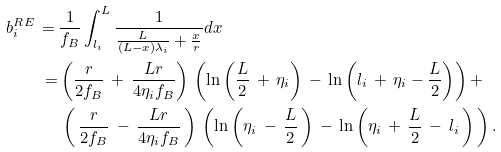<formula> <loc_0><loc_0><loc_500><loc_500>b _ { i } ^ { R E } \, = \, & \frac { 1 } { f _ { B } } \int _ { l _ { i } } ^ { L } \frac { 1 } { \frac { L } { ( L - x ) \lambda _ { i } } + \frac { x } { r } } d x \\ = & \left ( \frac { r } { 2 f _ { B } } \, + \, \frac { L r } { 4 \eta _ { i } f _ { B } } \right ) \, \left ( \ln \left ( \frac { L } { 2 } \, + \, \eta _ { i } \right ) \, - \, \ln \left ( l _ { i } \, + \, \eta _ { i } - \frac { L } { 2 } \right ) \right ) + \\ & \, \left ( \, \frac { r } { 2 f _ { B } } \, - \, \frac { L r } { 4 \eta _ { i } f _ { B } } \, \right ) \, \left ( \ln \left ( \eta _ { i } \, - \, \frac { L } { 2 } \, \right ) \, - \, \ln \left ( \eta _ { i } \, + \, \frac { L } { 2 } \, - \, l _ { i } \, \right ) \, \right ) .</formula> 